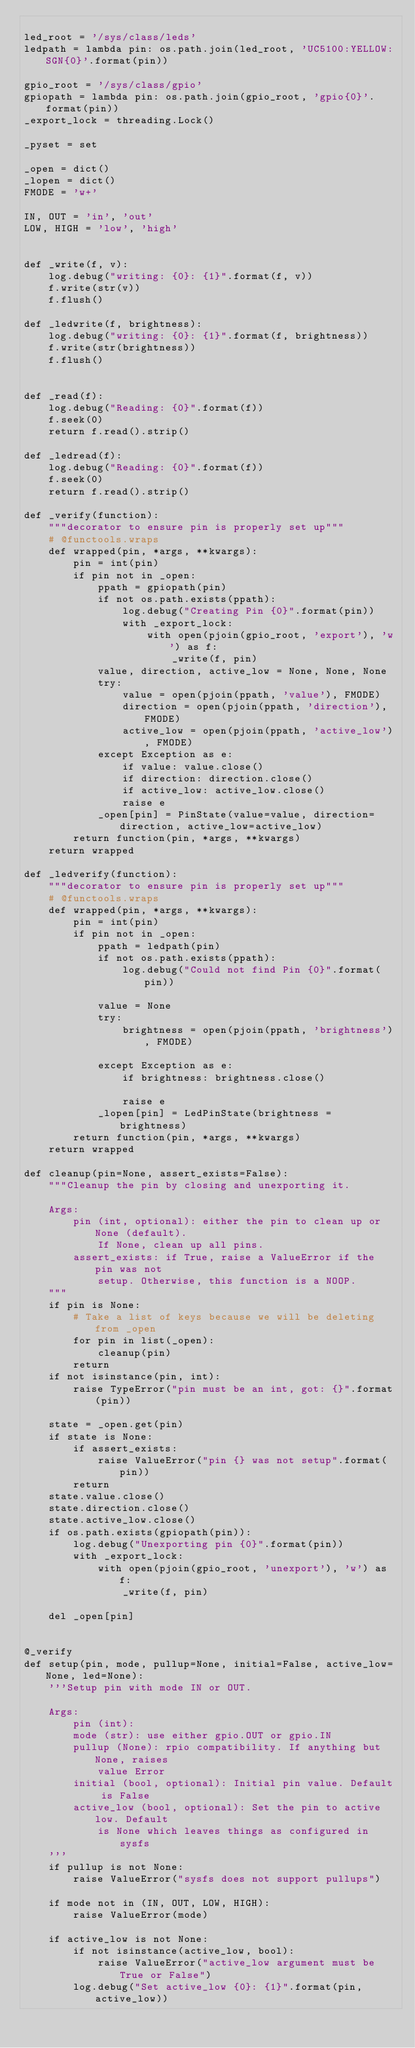<code> <loc_0><loc_0><loc_500><loc_500><_Python_>
led_root = '/sys/class/leds'
ledpath = lambda pin: os.path.join(led_root, 'UC5100:YELLOW:SGN{0}'.format(pin))

gpio_root = '/sys/class/gpio'
gpiopath = lambda pin: os.path.join(gpio_root, 'gpio{0}'.format(pin))
_export_lock = threading.Lock()

_pyset = set

_open = dict()
_lopen = dict()
FMODE = 'w+'

IN, OUT = 'in', 'out'
LOW, HIGH = 'low', 'high'


def _write(f, v):
    log.debug("writing: {0}: {1}".format(f, v))
    f.write(str(v))
    f.flush()

def _ledwrite(f, brightness):
    log.debug("writing: {0}: {1}".format(f, brightness))
    f.write(str(brightness))
    f.flush()


def _read(f):
    log.debug("Reading: {0}".format(f))
    f.seek(0)
    return f.read().strip()

def _ledread(f):
    log.debug("Reading: {0}".format(f))
    f.seek(0)
    return f.read().strip()

def _verify(function):
    """decorator to ensure pin is properly set up"""
    # @functools.wraps
    def wrapped(pin, *args, **kwargs):
        pin = int(pin)
        if pin not in _open:
            ppath = gpiopath(pin)
            if not os.path.exists(ppath):
                log.debug("Creating Pin {0}".format(pin))
                with _export_lock:
                    with open(pjoin(gpio_root, 'export'), 'w') as f:
                        _write(f, pin)
            value, direction, active_low = None, None, None
            try:
                value = open(pjoin(ppath, 'value'), FMODE)
                direction = open(pjoin(ppath, 'direction'), FMODE)
                active_low = open(pjoin(ppath, 'active_low'), FMODE)
            except Exception as e:
                if value: value.close()
                if direction: direction.close()
                if active_low: active_low.close()
                raise e
            _open[pin] = PinState(value=value, direction=direction, active_low=active_low)
        return function(pin, *args, **kwargs)
    return wrapped

def _ledverify(function):
    """decorator to ensure pin is properly set up"""
    # @functools.wraps
    def wrapped(pin, *args, **kwargs):
        pin = int(pin)
        if pin not in _open:
            ppath = ledpath(pin)
            if not os.path.exists(ppath):
                log.debug("Could not find Pin {0}".format(pin))
                
            value = None
            try:
                brightness = open(pjoin(ppath, 'brightness'), FMODE)
                
            except Exception as e:
                if brightness: brightness.close()
                
                raise e
            _lopen[pin] = LedPinState(brightness = brightness)
        return function(pin, *args, **kwargs)
    return wrapped

def cleanup(pin=None, assert_exists=False):
    """Cleanup the pin by closing and unexporting it.

    Args:
        pin (int, optional): either the pin to clean up or None (default).
            If None, clean up all pins.
        assert_exists: if True, raise a ValueError if the pin was not
            setup. Otherwise, this function is a NOOP.
    """
    if pin is None:
        # Take a list of keys because we will be deleting from _open
        for pin in list(_open):
            cleanup(pin)
        return
    if not isinstance(pin, int):
        raise TypeError("pin must be an int, got: {}".format(pin))

    state = _open.get(pin)
    if state is None:
        if assert_exists:
            raise ValueError("pin {} was not setup".format(pin))
        return
    state.value.close()
    state.direction.close()
    state.active_low.close()
    if os.path.exists(gpiopath(pin)):
        log.debug("Unexporting pin {0}".format(pin))
        with _export_lock:
            with open(pjoin(gpio_root, 'unexport'), 'w') as f:
                _write(f, pin)

    del _open[pin]


@_verify
def setup(pin, mode, pullup=None, initial=False, active_low=None, led=None):
    '''Setup pin with mode IN or OUT.

    Args:
        pin (int):
        mode (str): use either gpio.OUT or gpio.IN
        pullup (None): rpio compatibility. If anything but None, raises
            value Error
        initial (bool, optional): Initial pin value. Default is False
        active_low (bool, optional): Set the pin to active low. Default
            is None which leaves things as configured in sysfs
    '''
    if pullup is not None:
        raise ValueError("sysfs does not support pullups")

    if mode not in (IN, OUT, LOW, HIGH):
        raise ValueError(mode)

    if active_low is not None:
        if not isinstance(active_low, bool):
            raise ValueError("active_low argument must be True or False")
        log.debug("Set active_low {0}: {1}".format(pin, active_low))</code> 